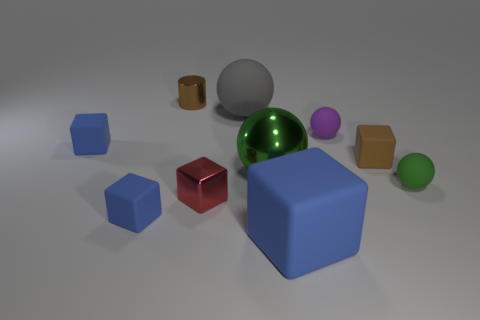Subtract all large green shiny spheres. How many spheres are left? 3 Subtract all cyan cylinders. How many green spheres are left? 2 Subtract all gray spheres. How many spheres are left? 3 Subtract 1 spheres. How many spheres are left? 3 Subtract all cylinders. How many objects are left? 9 Subtract all purple cylinders. Subtract all cyan cubes. How many cylinders are left? 1 Subtract all purple matte objects. Subtract all blue things. How many objects are left? 6 Add 9 brown shiny cylinders. How many brown shiny cylinders are left? 10 Add 5 small shiny objects. How many small shiny objects exist? 7 Subtract 0 green cylinders. How many objects are left? 10 